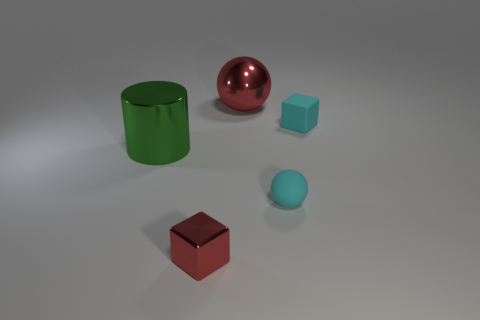Subtract all blocks. How many objects are left? 3 Subtract 1 cubes. How many cubes are left? 1 Subtract all tiny cyan metallic objects. Subtract all large red objects. How many objects are left? 4 Add 3 big metallic cylinders. How many big metallic cylinders are left? 4 Add 1 tiny cyan rubber spheres. How many tiny cyan rubber spheres exist? 2 Add 2 big green metal cylinders. How many objects exist? 7 Subtract all cyan cubes. How many cubes are left? 1 Subtract 0 gray cylinders. How many objects are left? 5 Subtract all blue blocks. Subtract all blue cylinders. How many blocks are left? 2 Subtract all cyan blocks. How many blue balls are left? 0 